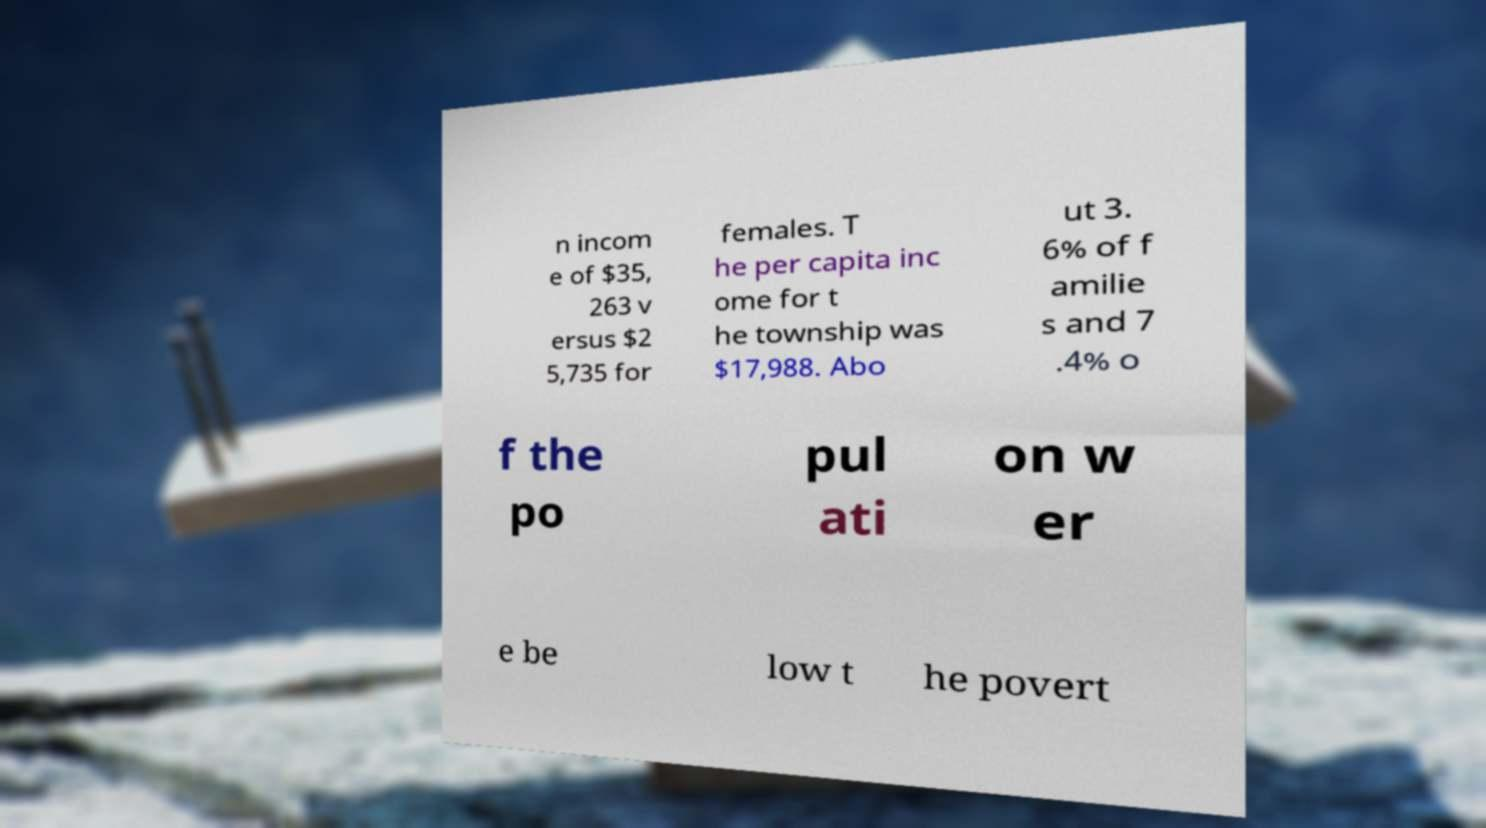Please identify and transcribe the text found in this image. n incom e of $35, 263 v ersus $2 5,735 for females. T he per capita inc ome for t he township was $17,988. Abo ut 3. 6% of f amilie s and 7 .4% o f the po pul ati on w er e be low t he povert 